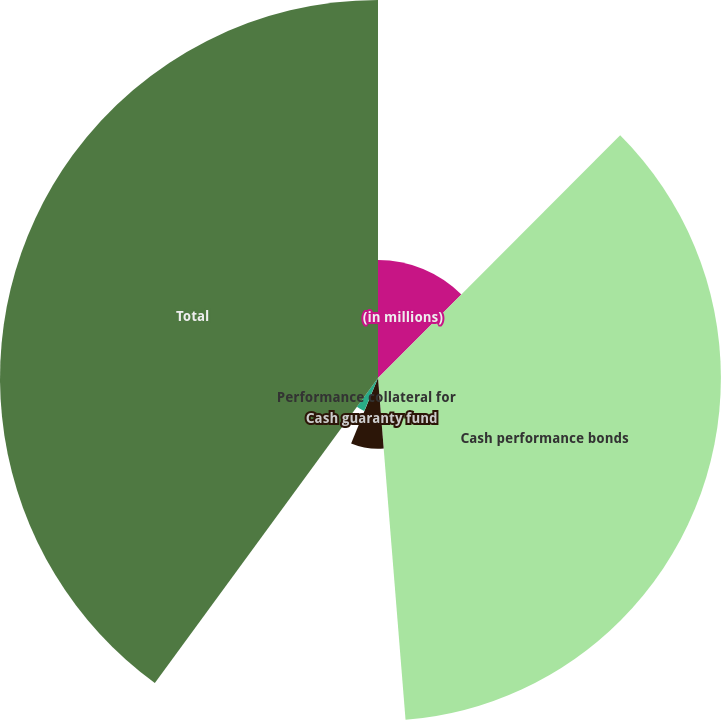Convert chart to OTSL. <chart><loc_0><loc_0><loc_500><loc_500><pie_chart><fcel>(in millions)<fcel>Cash performance bonds<fcel>Cash guaranty fund<fcel>Cross-margin arrangements<fcel>Performance collateral for<fcel>Total<nl><fcel>12.48%<fcel>36.24%<fcel>7.48%<fcel>0.07%<fcel>3.78%<fcel>39.95%<nl></chart> 